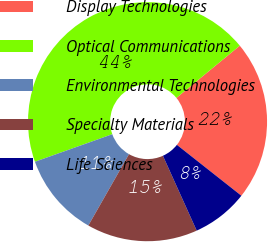Convert chart. <chart><loc_0><loc_0><loc_500><loc_500><pie_chart><fcel>Display Technologies<fcel>Optical Communications<fcel>Environmental Technologies<fcel>Specialty Materials<fcel>Life Sciences<nl><fcel>21.6%<fcel>44.47%<fcel>11.31%<fcel>14.99%<fcel>7.62%<nl></chart> 